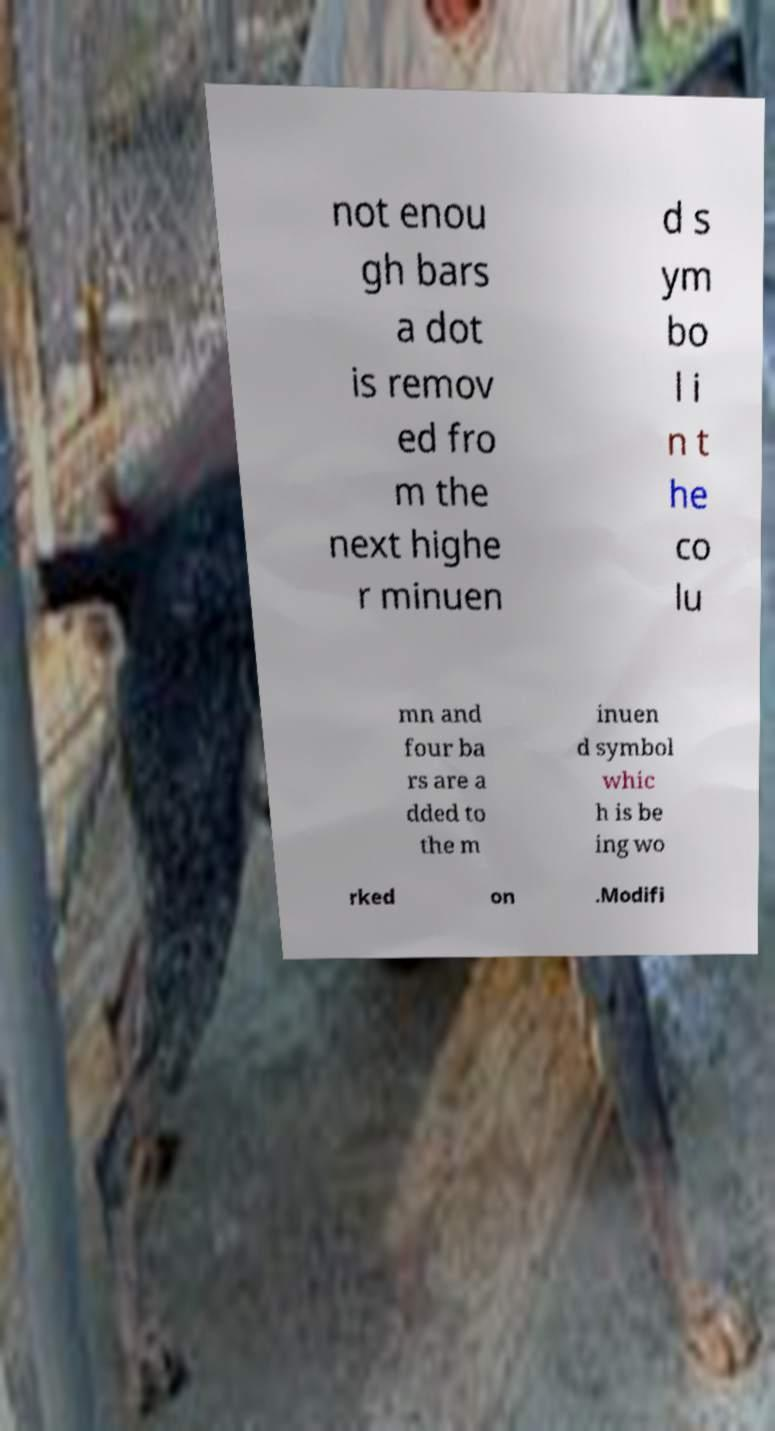Could you extract and type out the text from this image? not enou gh bars a dot is remov ed fro m the next highe r minuen d s ym bo l i n t he co lu mn and four ba rs are a dded to the m inuen d symbol whic h is be ing wo rked on .Modifi 